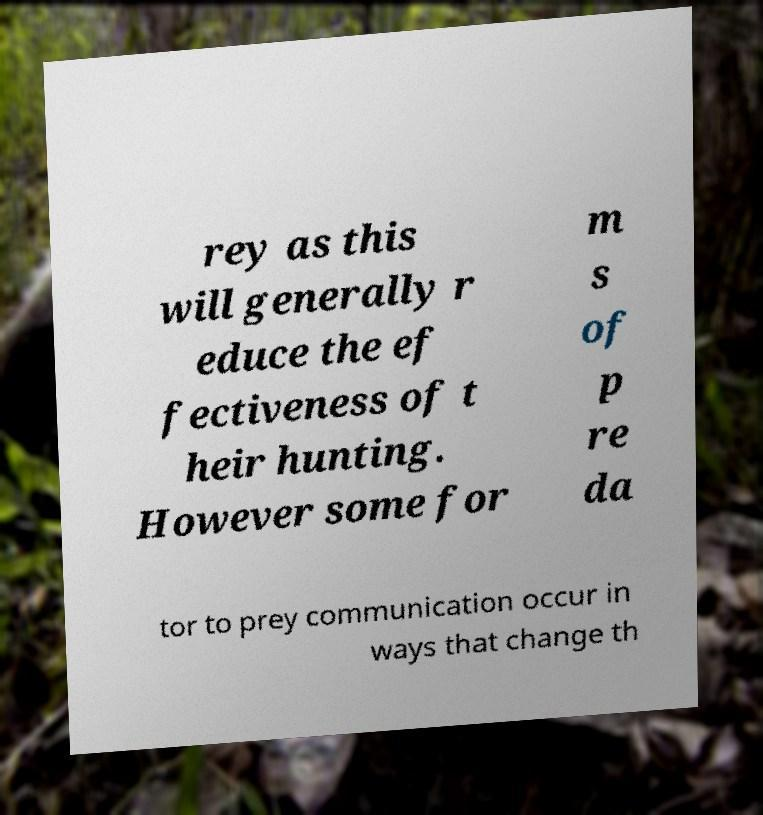Could you assist in decoding the text presented in this image and type it out clearly? rey as this will generally r educe the ef fectiveness of t heir hunting. However some for m s of p re da tor to prey communication occur in ways that change th 